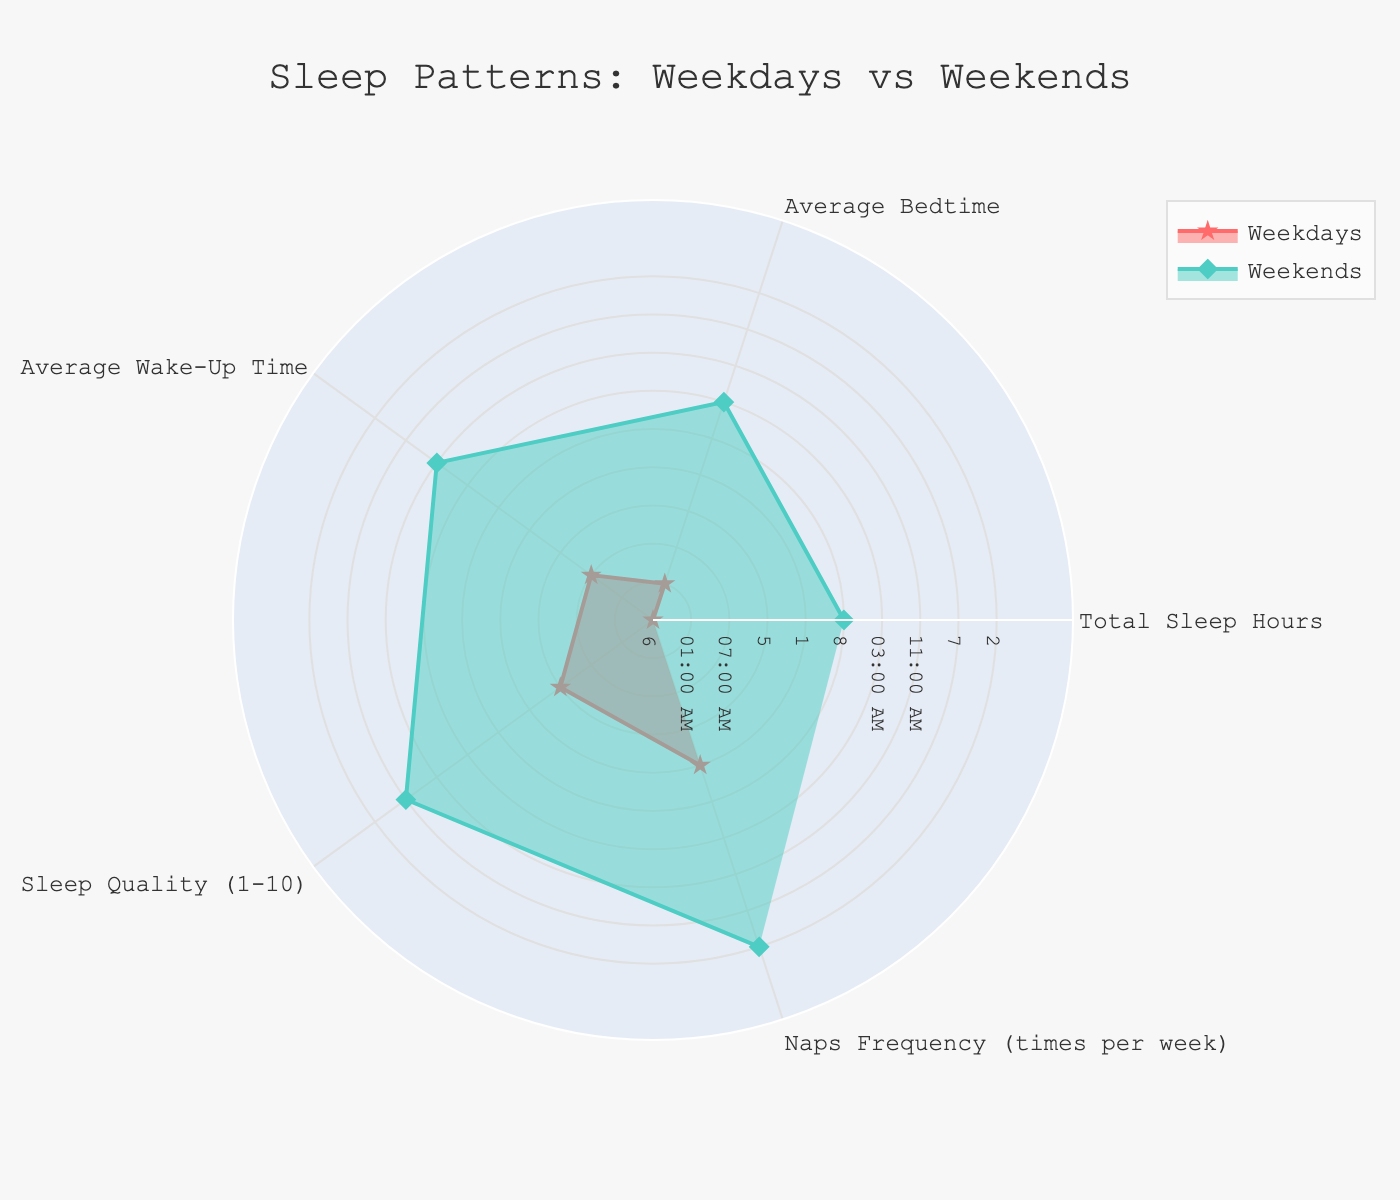What is the title of the radar chart? The title is indicated at the top of the chart.
Answer: Sleep Patterns: Weekdays vs Weekends Which sleep pattern has the highest total sleep hours? Look at the "Total Sleep Hours" category and compare the values for Weekdays and Weekends.
Answer: Weekends What is the average bedtime on Weekends? Check the value for the "Average Bedtime" category under the Weekends group.
Answer: 03:00 AM How many times per week do Naps occur? Refer to the "Naps Frequency (times per week)" category and find the value for Naps.
Answer: 7 times Which sleep pattern has the worst sleep quality? Compare the values for the "Sleep Quality (1-10)" category among all groups and choose the lowest.
Answer: All-nighters What is the difference in total sleep hours between Weekdays and Weekends? Subtract the total sleep hours for Weekdays from the total sleep hours for Weekends. 8 - 6 = 2
Answer: 2 hours Between Weekdays and Weekends, which has a later average wake-up time? Compare the "Average Wake-Up Time" values for Weekdays and Weekends.
Answer: Weekends Which day has more variability in sleep quality? Look at the range of sleep quality scores for all days and check the difference.
Answer: Weekends (3 units difference between Weekdays and Weekends) How many categories have the 'N/A' value in both Weekdays and Weekends? Examine the "Average Bedtime" and "Average Wake-Up Time" categories in both groups to count 'N/A' values.
Answer: 2 categories What is the frequency of Naps compared to All-nighters? Compare the value in "Naps Frequency (times per week)" for Naps and All-nighters. Calculated as 7 (Naps) - 0 (All-nighters).
Answer: 7 times more Between Weekdays and Weekends, which has the lower sleep quality on average? Compare the sleep quality scores for Weekdays and Weekends to find the lower value.
Answer: Weekdays 